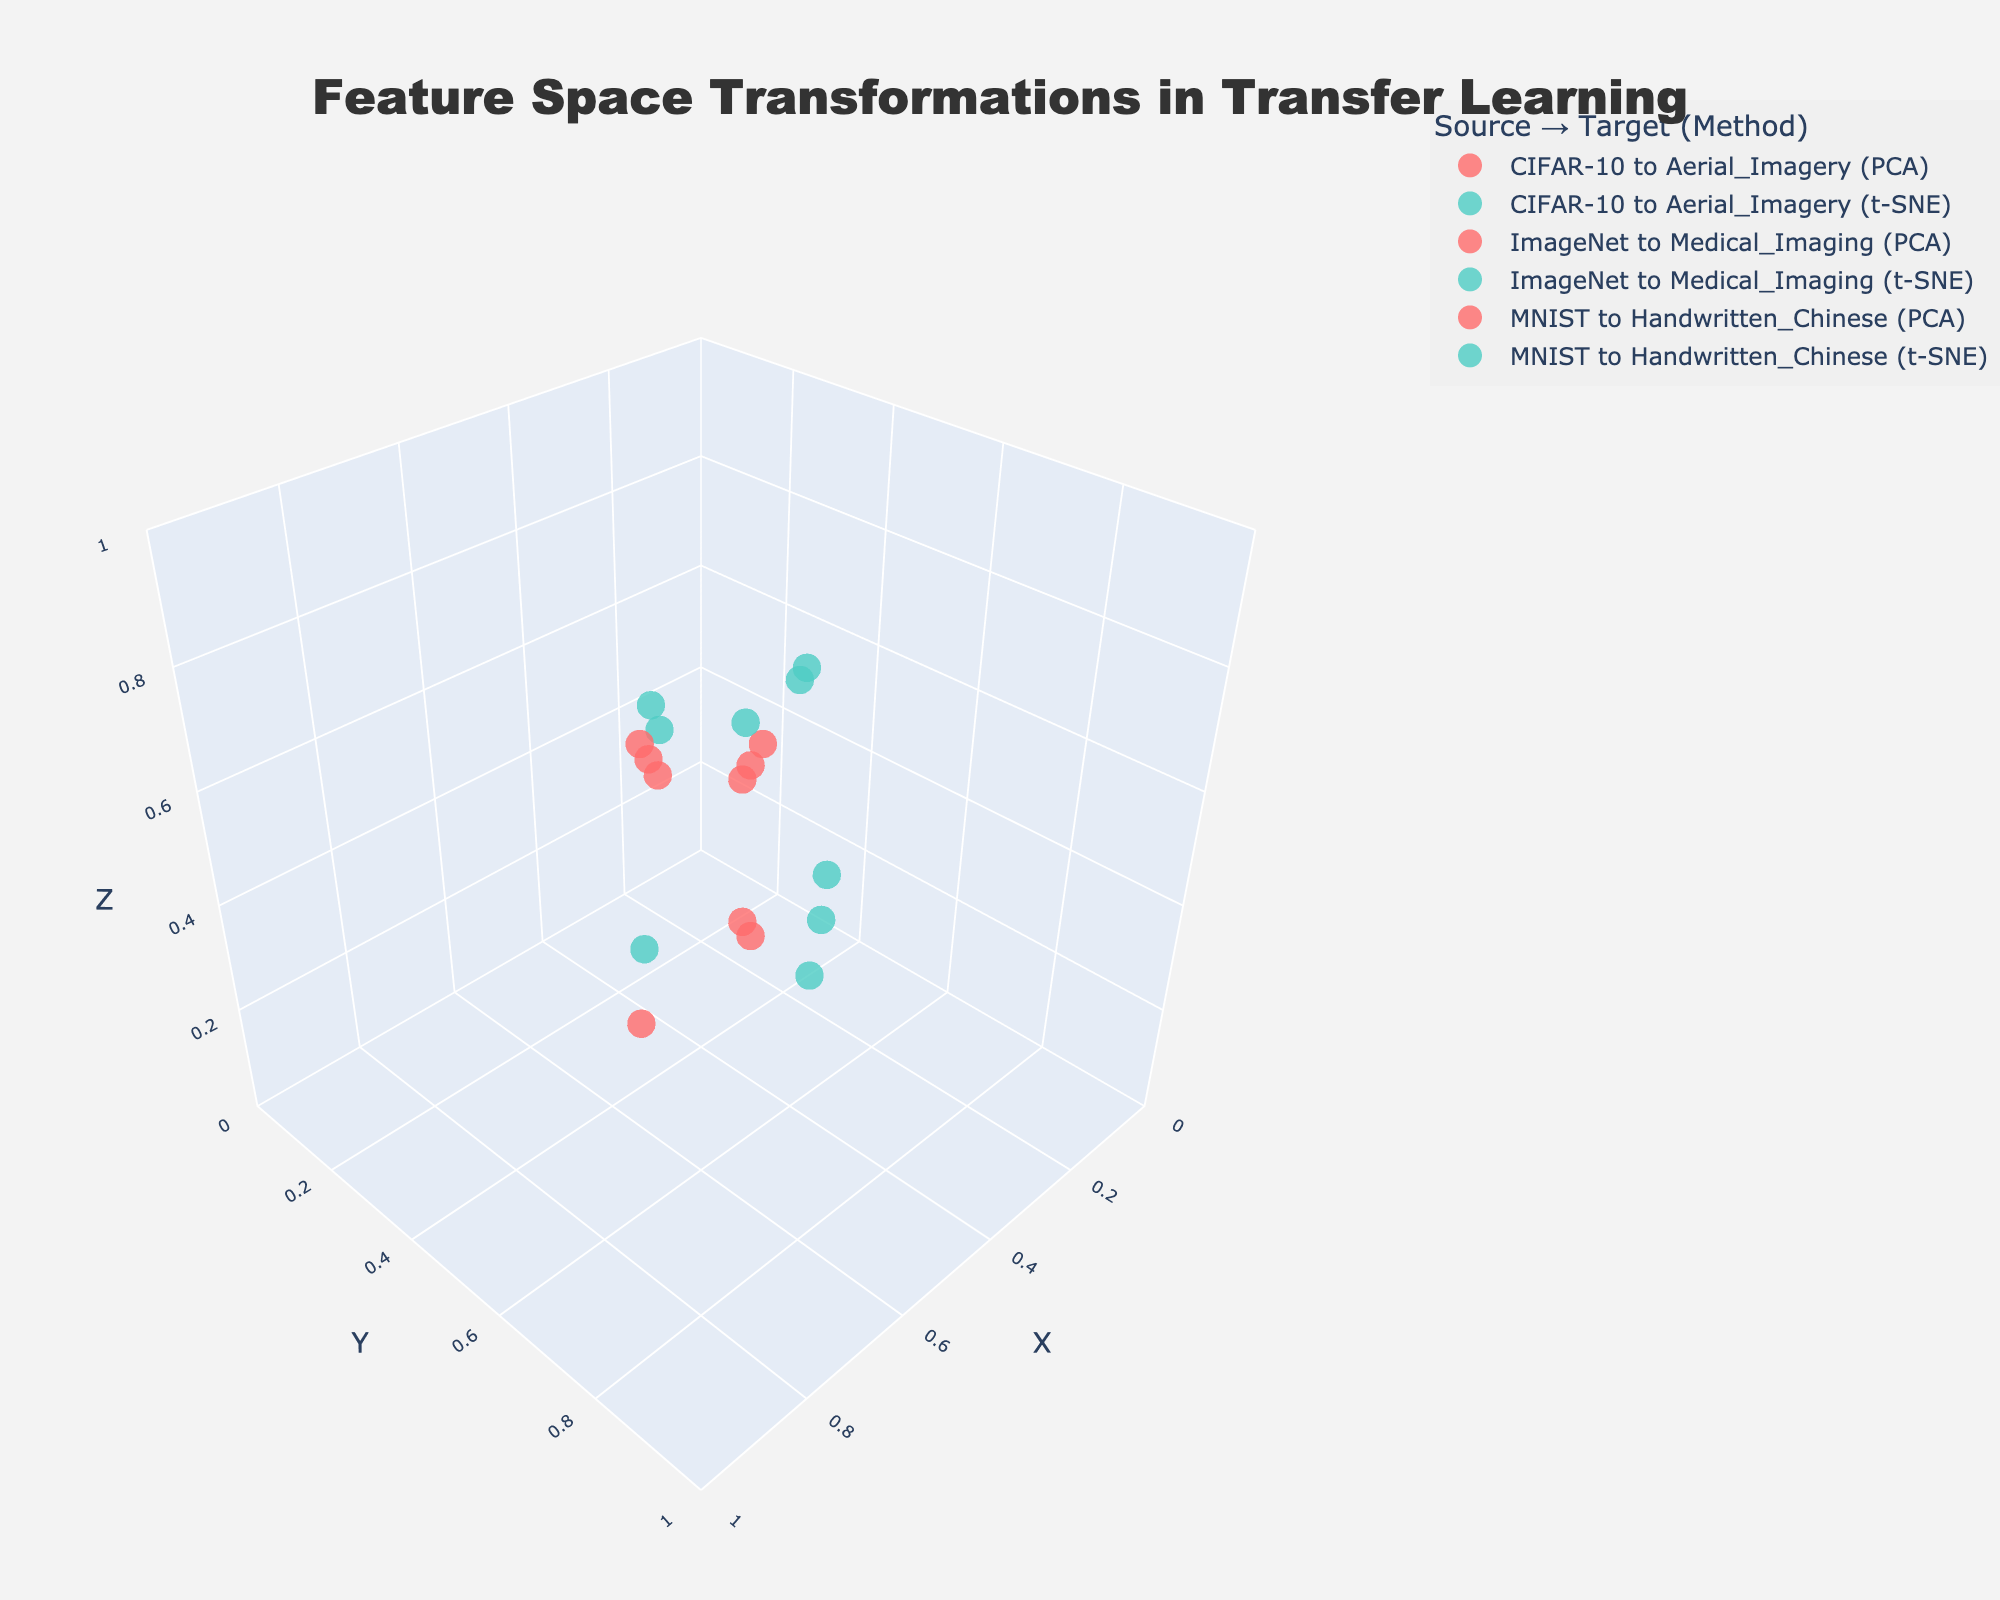What is the title of the figure? The title of the figure is displayed at the top of the visualization. It helps to understand what the entire plot represents.
Answer: "Feature Space Transformations in Transfer Learning" How many unique source-to-target domain transformations are shown in the figure? By looking at the legend, we can count all unique source-to-target domains mentioned.
Answer: 3 What colors represent PCA and t-SNE transformations? By referring to the legend, the colors associated with PCA and t-SNE transformations can be found.
Answer: PCA: Red, t-SNE: Green Which source-to-target transformation uses green markers? The legend shows that green markers represent the t-SNE transformation, so we need to find the transformations listed with t-SNE.
Answer: All source-to-target pairs using t-SNE How many data points are plotted for the MNIST to Handwritten_Chinese transformation using PCA? By looking at the MNIST to Handwritten_Chinese transformation within the visualization, we count the number of red (PCA) markers.
Answer: 3 Between ImageNet to Medical_Imaging and CIFAR-10 to Aerial_Imagery, which source-to-target transformation has a higher z-axis value in PCA? By comparing the z-axis values of PCA transformations for these two pairs, we observe which has higher points.
Answer: CIFAR-10 to Aerial_Imagery What is the average x-axis value for the t-SNE transformation from CIFAR-10 to Aerial_Imagery? The x-values for t-SNE from CIFAR-10 to Aerial_Imagery are 0.2, 0.5, and 0.8. The average is calculated as (0.2 + 0.5 + 0.8) / 3.
Answer: 0.5 Which transformation (PCA or t-SNE) exhibits a broader spread in the y-axis for ImageNet to Medical_Imaging? By visually examining the spread of markers along the y-axis for both PCA and t-SNE, the one with a wider range is identified.
Answer: t-SNE What are the coordinates of the highest z-value data point for MNIST to Handwritten_Chinese using PCA? We look for the highest value in the z-axis among the red markers for MNIST to Handwritten_Chinese and note the corresponding x and y values.
Answer: (0.9, 0.8, 0.6) How does the density of data points compare between PCA and t-SNE transformations within the CIFAR-10 to Aerial_Imagery domain? By observing the number of data points and their clustering density in the visualization for each transformation.
Answer: Similar density 